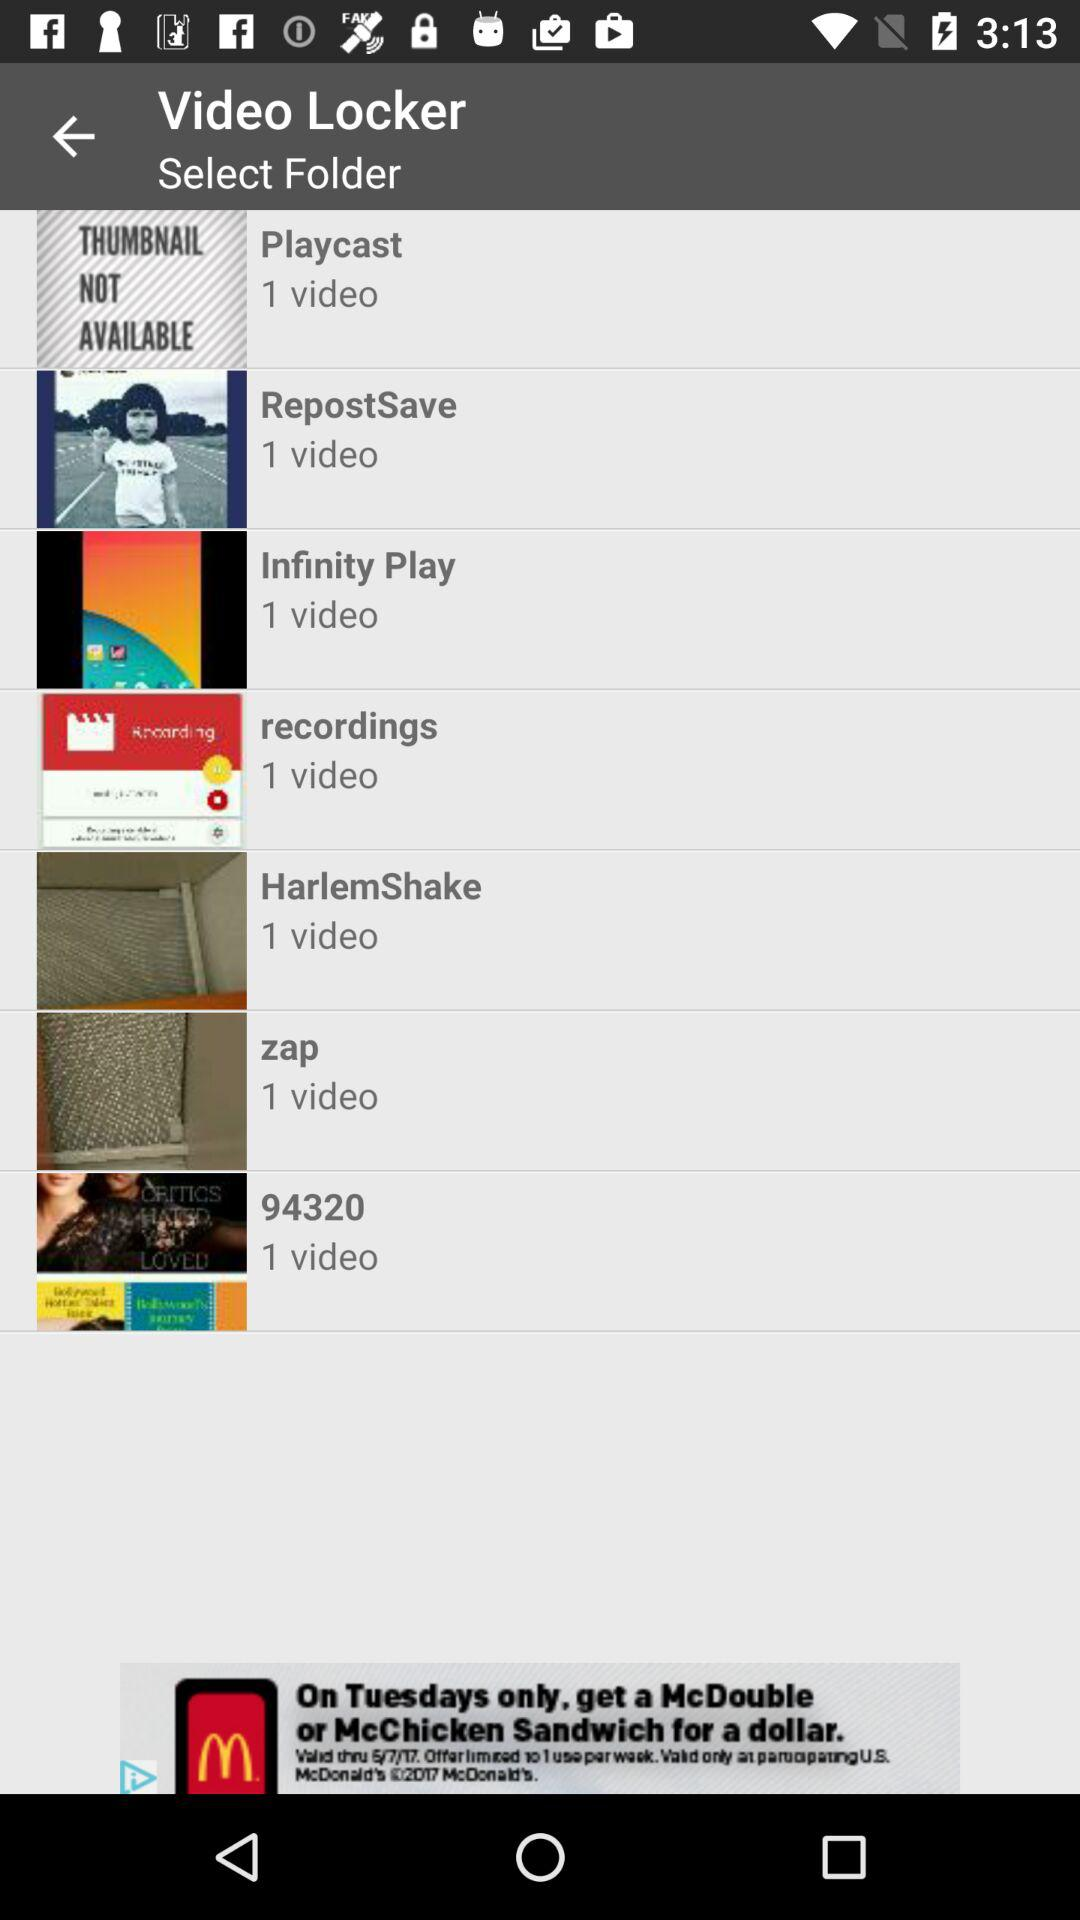What is the number of videos in Playcast folder? There is 1 video in the Playcast folder. 